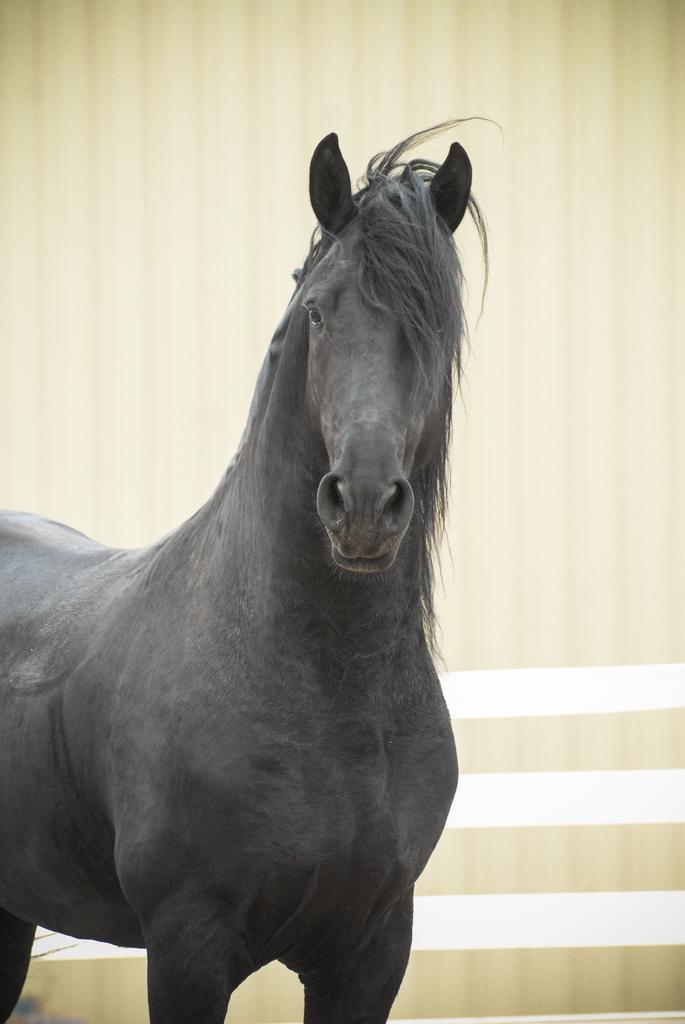What type of animal is in the image? The animal in the image is black in color. What can be seen in the background of the image? There is a cream and white color wall in the background of the image. What type of kettle is being used to recite a verse in the image? There is no kettle or verse present in the image; it only features a black animal and a cream and white color wall in the background. 